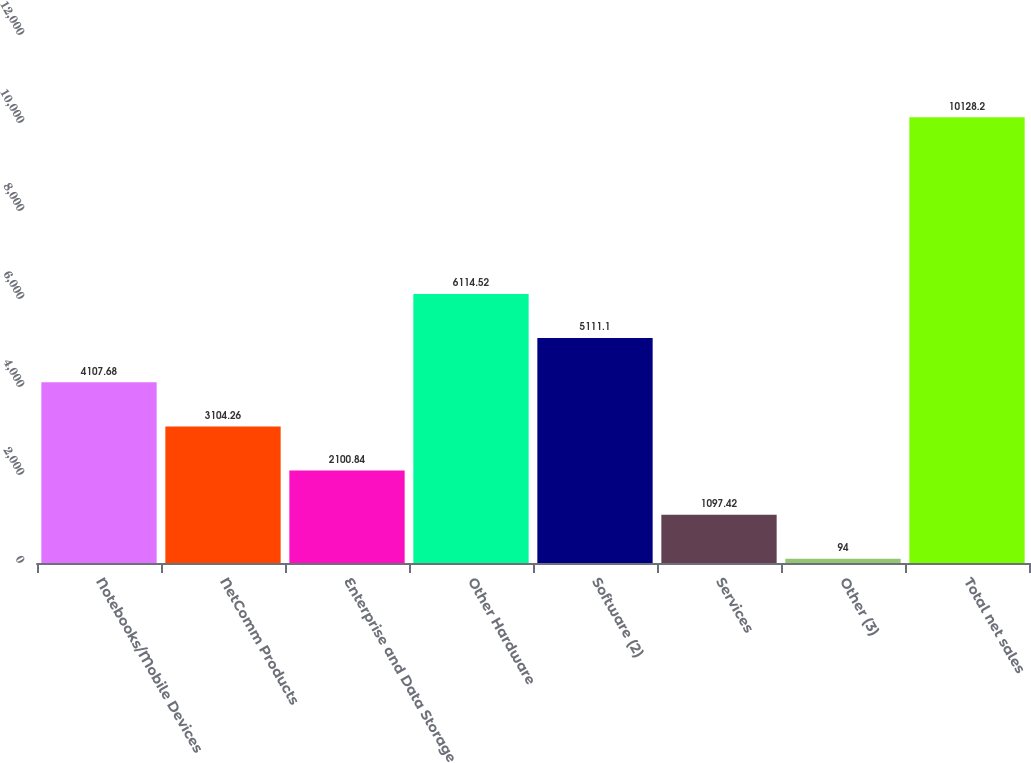Convert chart. <chart><loc_0><loc_0><loc_500><loc_500><bar_chart><fcel>Notebooks/Mobile Devices<fcel>NetComm Products<fcel>Enterprise and Data Storage<fcel>Other Hardware<fcel>Software (2)<fcel>Services<fcel>Other (3)<fcel>Total net sales<nl><fcel>4107.68<fcel>3104.26<fcel>2100.84<fcel>6114.52<fcel>5111.1<fcel>1097.42<fcel>94<fcel>10128.2<nl></chart> 